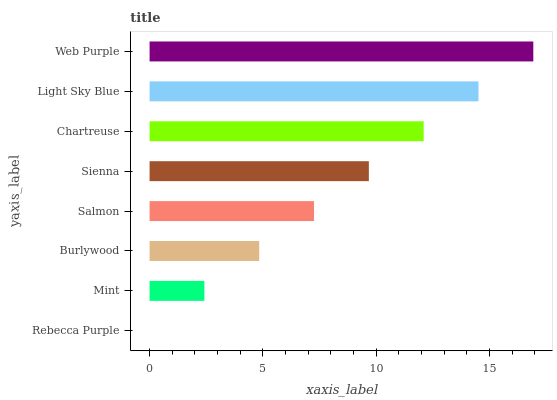Is Rebecca Purple the minimum?
Answer yes or no. Yes. Is Web Purple the maximum?
Answer yes or no. Yes. Is Mint the minimum?
Answer yes or no. No. Is Mint the maximum?
Answer yes or no. No. Is Mint greater than Rebecca Purple?
Answer yes or no. Yes. Is Rebecca Purple less than Mint?
Answer yes or no. Yes. Is Rebecca Purple greater than Mint?
Answer yes or no. No. Is Mint less than Rebecca Purple?
Answer yes or no. No. Is Sienna the high median?
Answer yes or no. Yes. Is Salmon the low median?
Answer yes or no. Yes. Is Burlywood the high median?
Answer yes or no. No. Is Web Purple the low median?
Answer yes or no. No. 